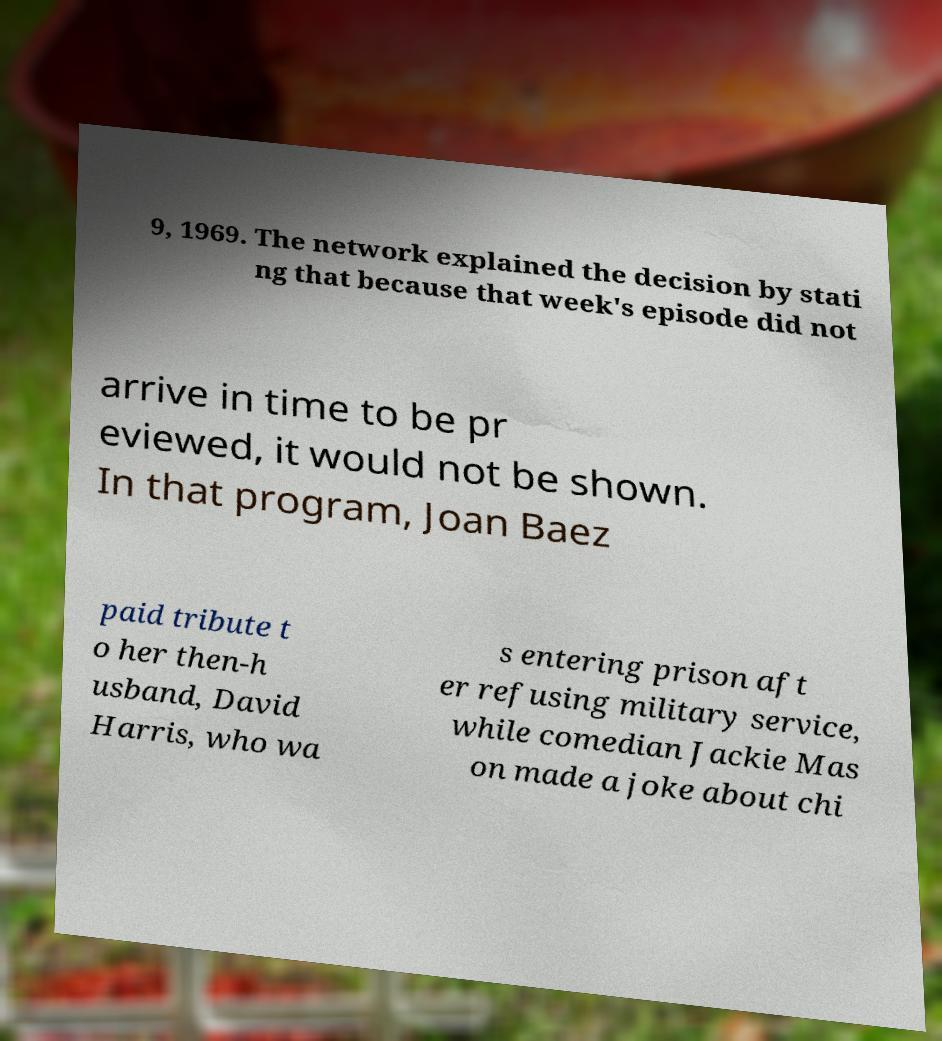For documentation purposes, I need the text within this image transcribed. Could you provide that? 9, 1969. The network explained the decision by stati ng that because that week's episode did not arrive in time to be pr eviewed, it would not be shown. In that program, Joan Baez paid tribute t o her then-h usband, David Harris, who wa s entering prison aft er refusing military service, while comedian Jackie Mas on made a joke about chi 